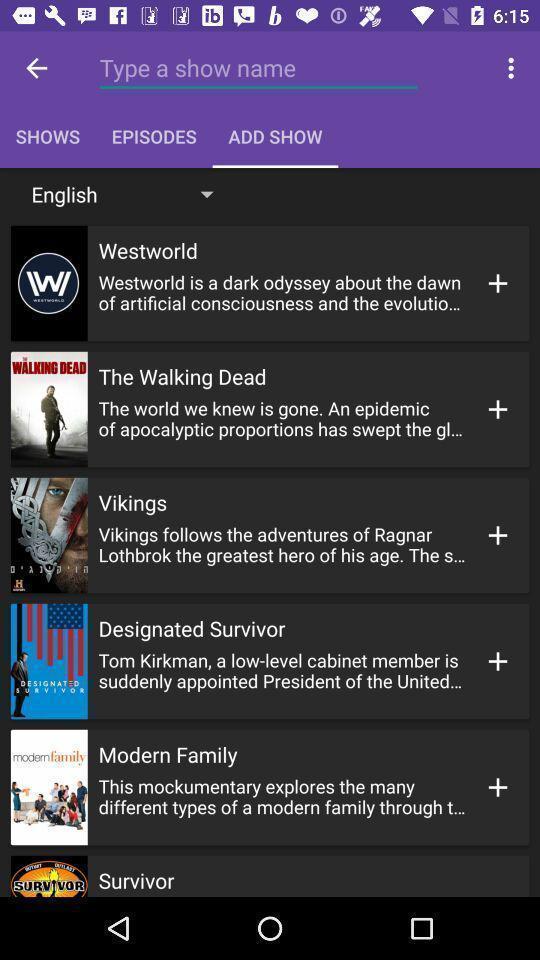What can you discern from this picture? Screen shows list of shows. 